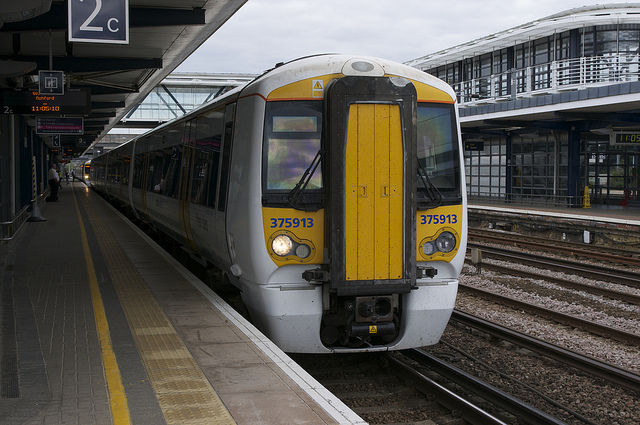Identify the text contained in this image. 375913 375913 11'05 2C C 2 